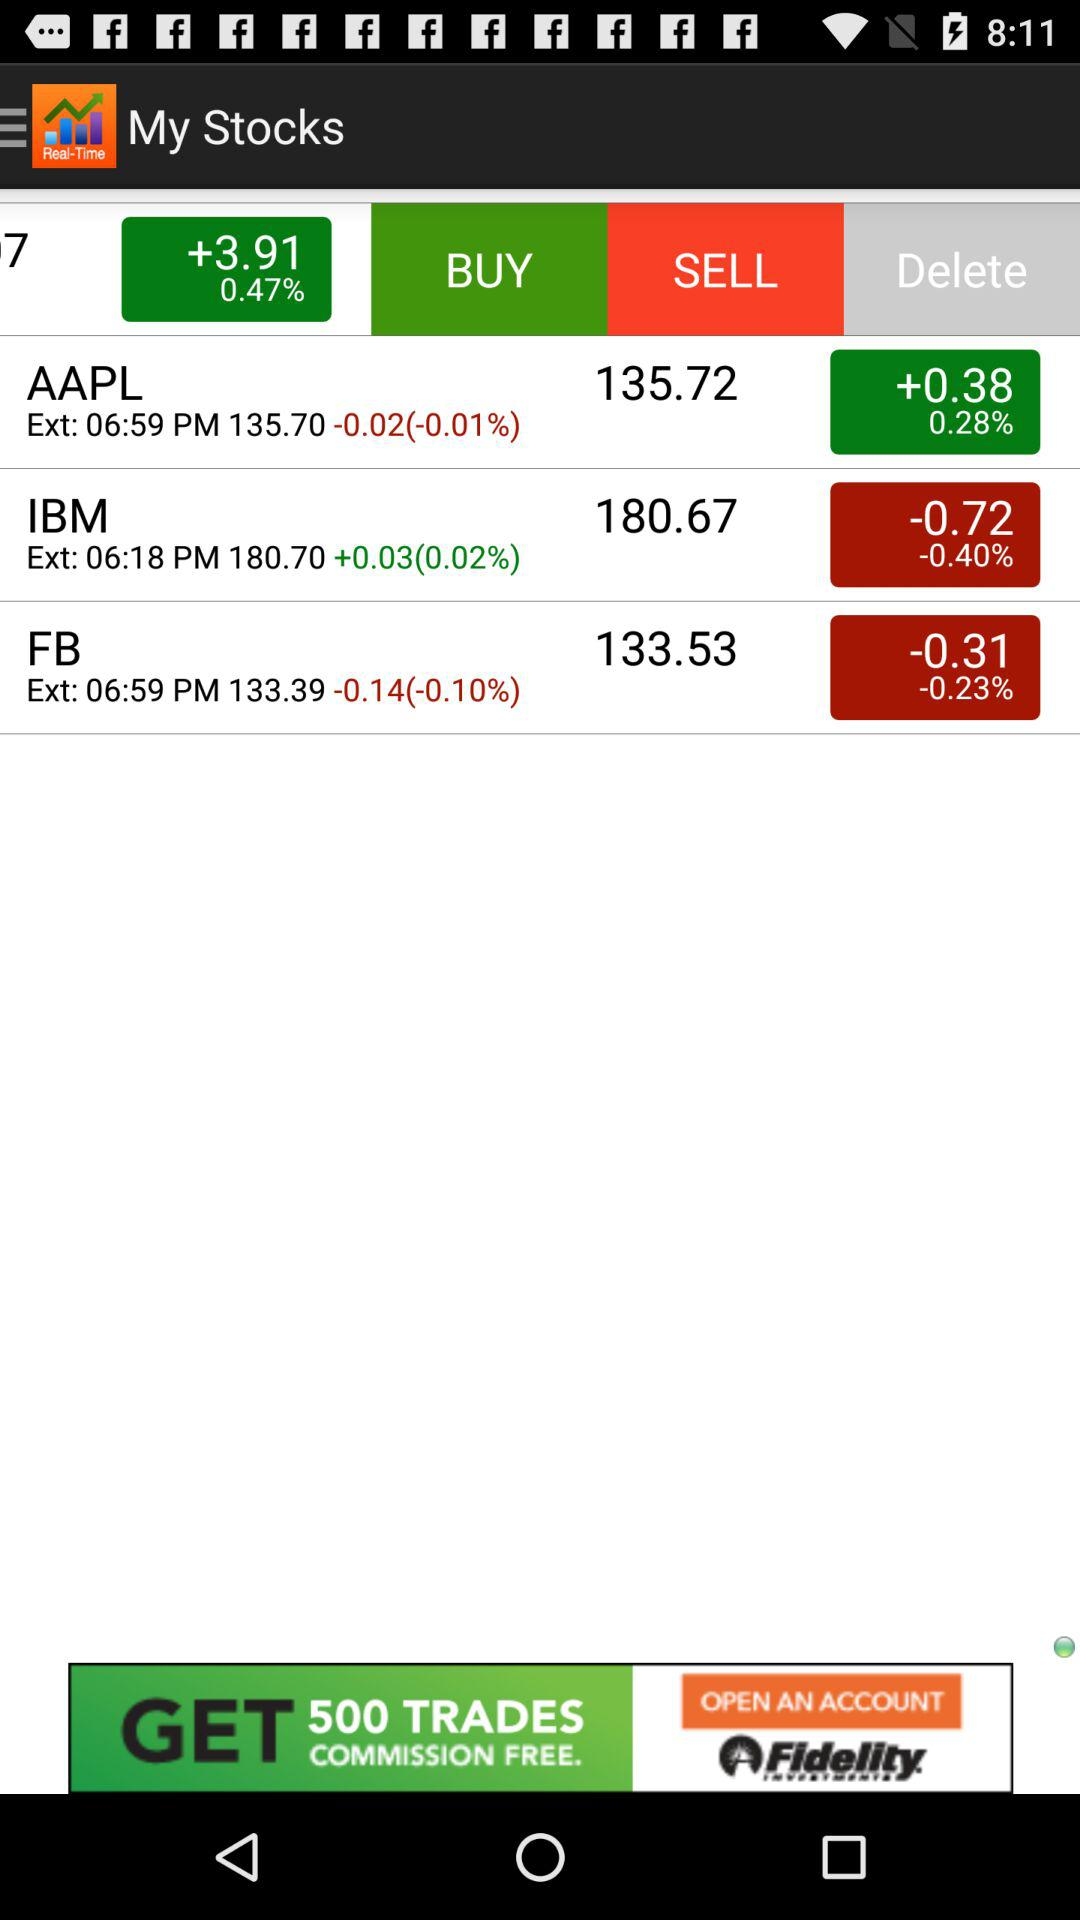What is the application name? The application name is "Stocks Tracker:Real-time stock". 